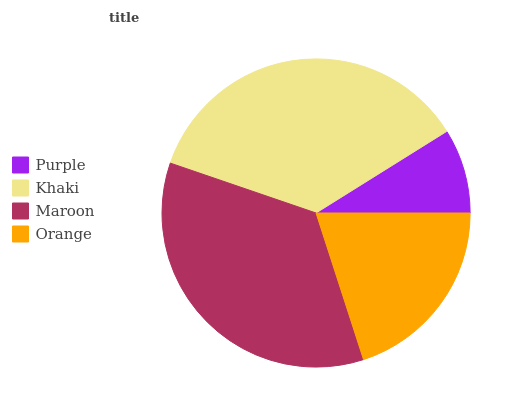Is Purple the minimum?
Answer yes or no. Yes. Is Khaki the maximum?
Answer yes or no. Yes. Is Maroon the minimum?
Answer yes or no. No. Is Maroon the maximum?
Answer yes or no. No. Is Khaki greater than Maroon?
Answer yes or no. Yes. Is Maroon less than Khaki?
Answer yes or no. Yes. Is Maroon greater than Khaki?
Answer yes or no. No. Is Khaki less than Maroon?
Answer yes or no. No. Is Maroon the high median?
Answer yes or no. Yes. Is Orange the low median?
Answer yes or no. Yes. Is Orange the high median?
Answer yes or no. No. Is Purple the low median?
Answer yes or no. No. 